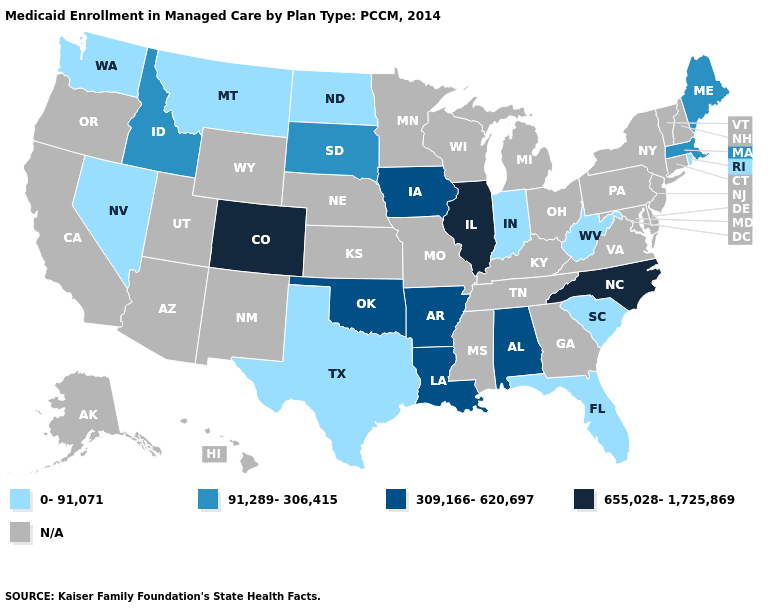What is the value of Georgia?
Give a very brief answer. N/A. Name the states that have a value in the range 0-91,071?
Quick response, please. Florida, Indiana, Montana, Nevada, North Dakota, Rhode Island, South Carolina, Texas, Washington, West Virginia. Name the states that have a value in the range 0-91,071?
Give a very brief answer. Florida, Indiana, Montana, Nevada, North Dakota, Rhode Island, South Carolina, Texas, Washington, West Virginia. What is the highest value in the Northeast ?
Keep it brief. 91,289-306,415. What is the value of Arkansas?
Give a very brief answer. 309,166-620,697. Name the states that have a value in the range 309,166-620,697?
Give a very brief answer. Alabama, Arkansas, Iowa, Louisiana, Oklahoma. Among the states that border Tennessee , does Arkansas have the highest value?
Be succinct. No. Name the states that have a value in the range N/A?
Keep it brief. Alaska, Arizona, California, Connecticut, Delaware, Georgia, Hawaii, Kansas, Kentucky, Maryland, Michigan, Minnesota, Mississippi, Missouri, Nebraska, New Hampshire, New Jersey, New Mexico, New York, Ohio, Oregon, Pennsylvania, Tennessee, Utah, Vermont, Virginia, Wisconsin, Wyoming. What is the value of California?
Concise answer only. N/A. What is the value of Virginia?
Short answer required. N/A. Among the states that border Illinois , does Indiana have the lowest value?
Concise answer only. Yes. What is the value of Nevada?
Quick response, please. 0-91,071. 